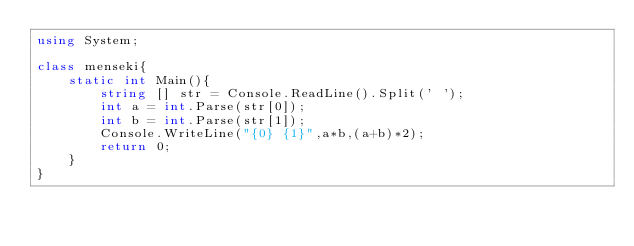Convert code to text. <code><loc_0><loc_0><loc_500><loc_500><_C#_>using System;

class menseki{
    static int Main(){
        string [] str = Console.ReadLine().Split(' ');
        int a = int.Parse(str[0]);
        int b = int.Parse(str[1]);
        Console.WriteLine("{0} {1}",a*b,(a+b)*2);
        return 0;
    }
}
</code> 